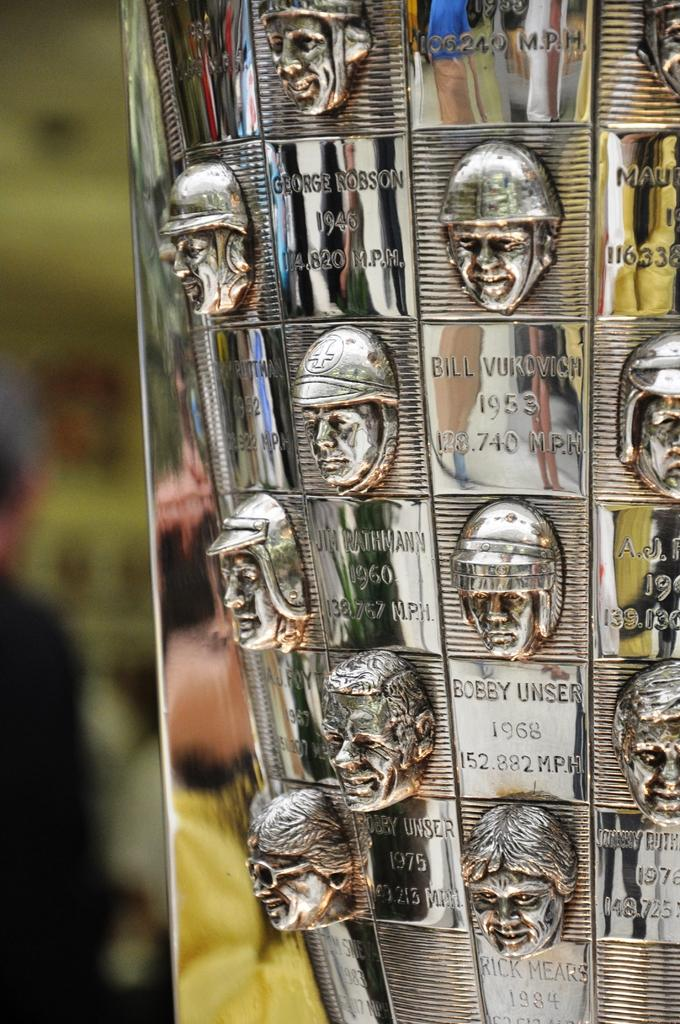What type of material is the surface with the engravings made of? The surface with the engravings is made of metal. What can be seen on the metal surface? There are human faces engraved on the metal surface. Where is the map located in the image? There is no map present in the image; it only features human faces engraved on a metal surface. 